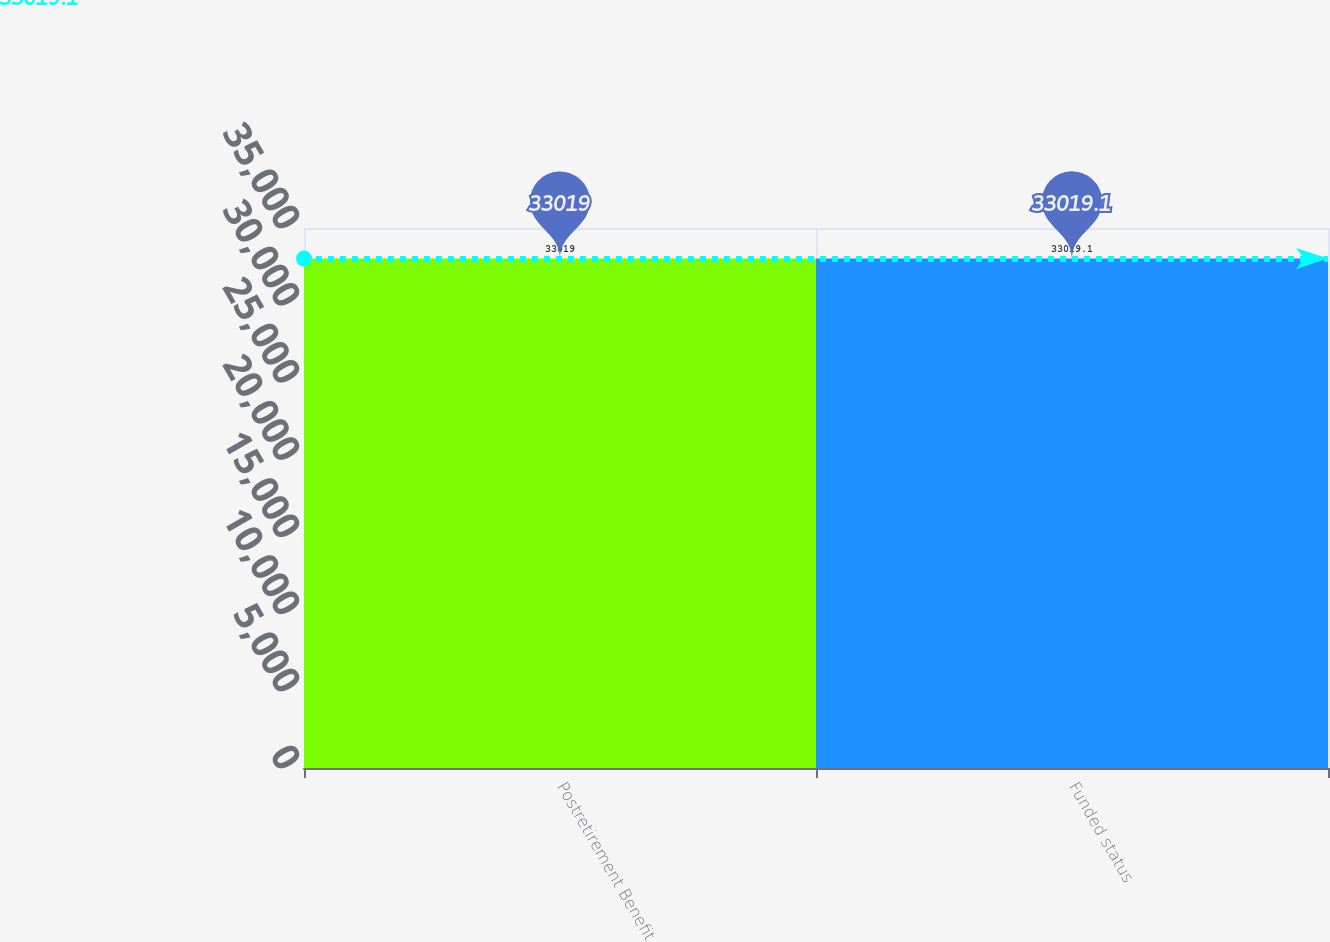Convert chart. <chart><loc_0><loc_0><loc_500><loc_500><bar_chart><fcel>Postretirement Benefit<fcel>Funded status<nl><fcel>33019<fcel>33019.1<nl></chart> 